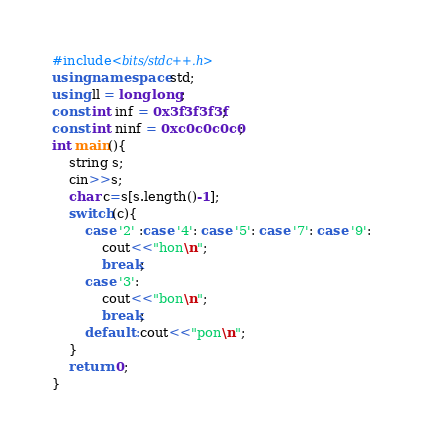Convert code to text. <code><loc_0><loc_0><loc_500><loc_500><_C++_>#include<bits/stdc++.h>
using namespace std;
using ll = long long;
const int inf = 0x3f3f3f3f;
const int ninf = 0xc0c0c0c0;
int main(){
	string s;
	cin>>s;
	char c=s[s.length()-1];
	switch(c){
		case '2' :case '4': case '5': case '7': case '9': 
			cout<<"hon\n";
			break;
		case '3':
			cout<<"bon\n";
			break;
		default :cout<<"pon\n"; 
	}
	return 0;
}</code> 